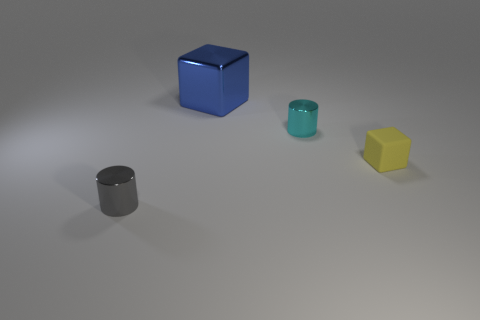Is there a gray object that has the same size as the matte block?
Ensure brevity in your answer.  Yes. Is the number of small gray things to the left of the gray object less than the number of gray objects?
Your answer should be very brief. Yes. Is the number of objects that are to the right of the big thing less than the number of things that are to the left of the small rubber cube?
Provide a succinct answer. Yes. How many spheres are purple objects or small gray objects?
Your response must be concise. 0. Are the cylinder that is behind the yellow rubber object and the thing right of the cyan object made of the same material?
Your response must be concise. No. What is the shape of the cyan thing that is the same size as the yellow rubber object?
Provide a short and direct response. Cylinder. What number of other things are there of the same color as the rubber cube?
Keep it short and to the point. 0. How many blue things are big blocks or cubes?
Your response must be concise. 1. Is the shape of the tiny thing in front of the matte object the same as the small metal object that is behind the gray cylinder?
Keep it short and to the point. Yes. How many other things are there of the same material as the small gray object?
Keep it short and to the point. 2. 